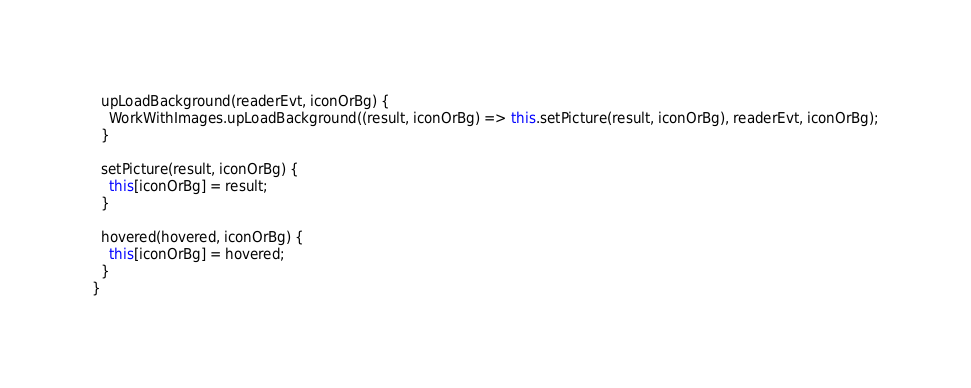Convert code to text. <code><loc_0><loc_0><loc_500><loc_500><_TypeScript_>
  upLoadBackground(readerEvt, iconOrBg) {
    WorkWithImages.upLoadBackground((result, iconOrBg) => this.setPicture(result, iconOrBg), readerEvt, iconOrBg);
  }

  setPicture(result, iconOrBg) {
    this[iconOrBg] = result;
  }

  hovered(hovered, iconOrBg) {
    this[iconOrBg] = hovered;
  }
}
</code> 